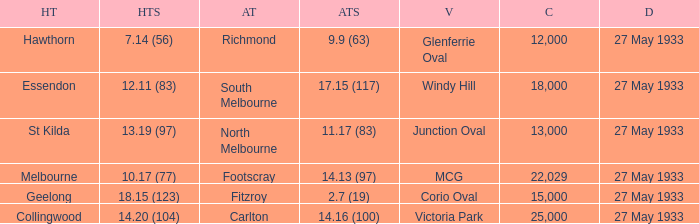During st kilda's home game, what was the number of people in the crowd? 13000.0. 